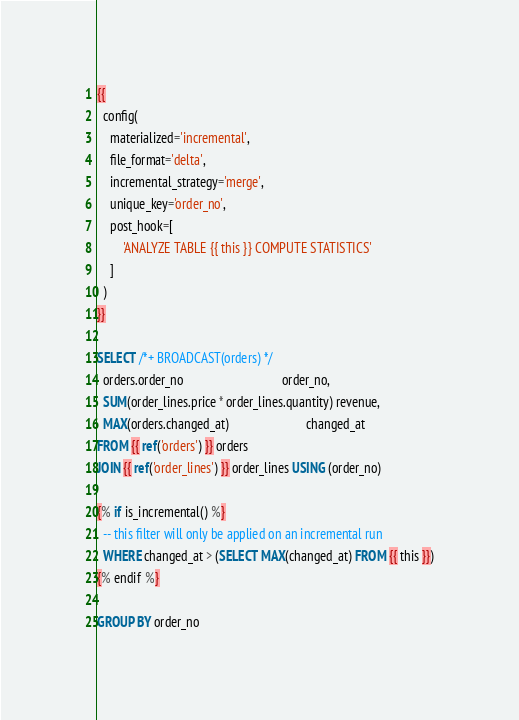<code> <loc_0><loc_0><loc_500><loc_500><_SQL_>{{
  config(
    materialized='incremental',
    file_format='delta',
    incremental_strategy='merge',
    unique_key='order_no',
    post_hook=[
        'ANALYZE TABLE {{ this }} COMPUTE STATISTICS'
    ]
  )
}}

SELECT /*+ BROADCAST(orders) */
  orders.order_no                               order_no,
  SUM(order_lines.price * order_lines.quantity) revenue,
  MAX(orders.changed_at)                        changed_at
FROM {{ ref('orders') }} orders
JOIN {{ ref('order_lines') }} order_lines USING (order_no)

{% if is_incremental() %}
  -- this filter will only be applied on an incremental run
  WHERE changed_at > (SELECT MAX(changed_at) FROM {{ this }})
{% endif %}

GROUP BY order_no
</code> 